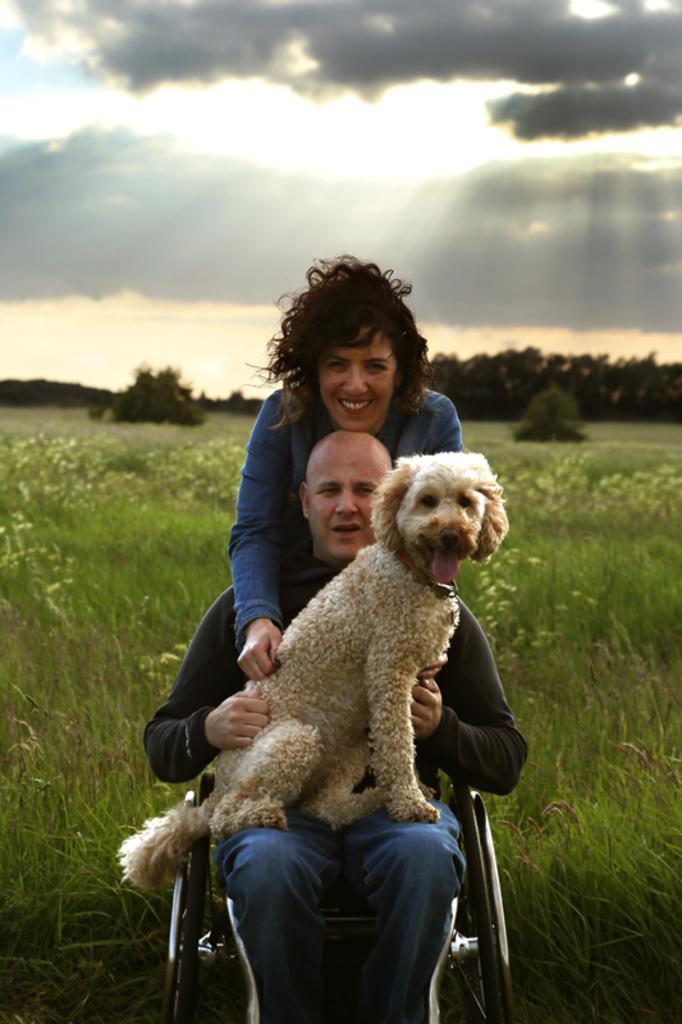Describe this image in one or two sentences. This is the picture of a person sitting on the wheelchair holding a dog and a lady is back of the man and behind them there are some plants and grass and also the sky. 